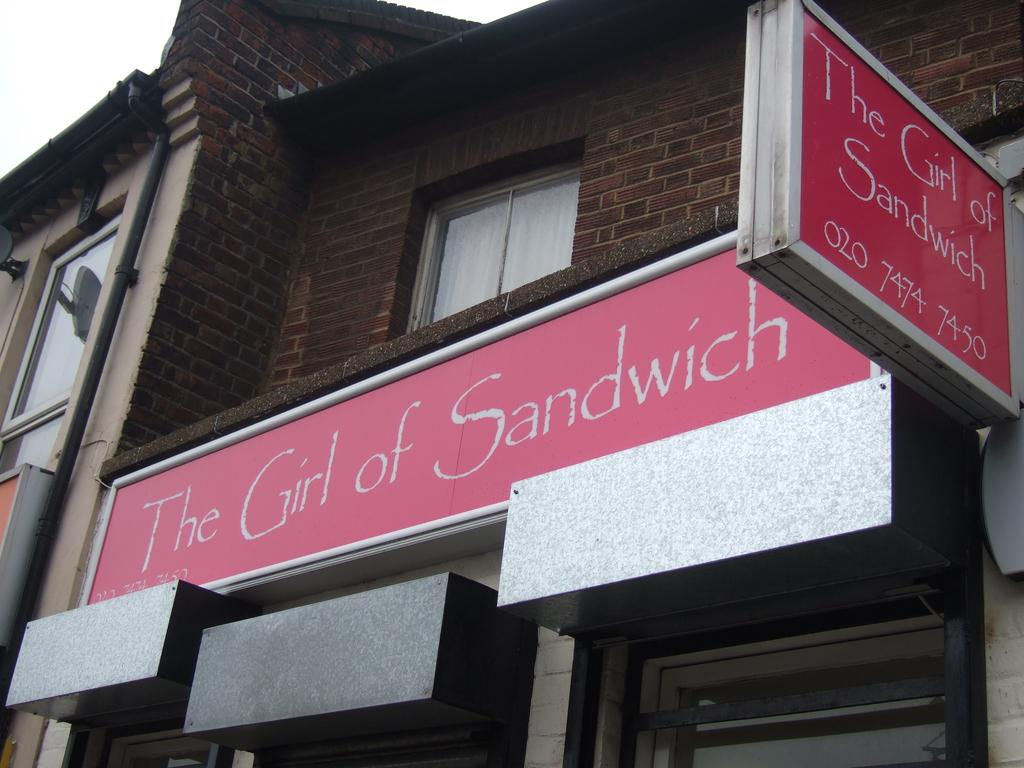What is the main structure in the image? There is a building in the image. Are there any additional features attached to the building? Yes, there are two boards with text attached to the building. What can be seen in the background of the image? The sky is visible in the background of the image. Where is the zoo located in the image? There is no zoo present in the image. What type of pin is holding the boards to the building? There is no pin mentioned or visible in the image; the boards are simply attached to the building. 